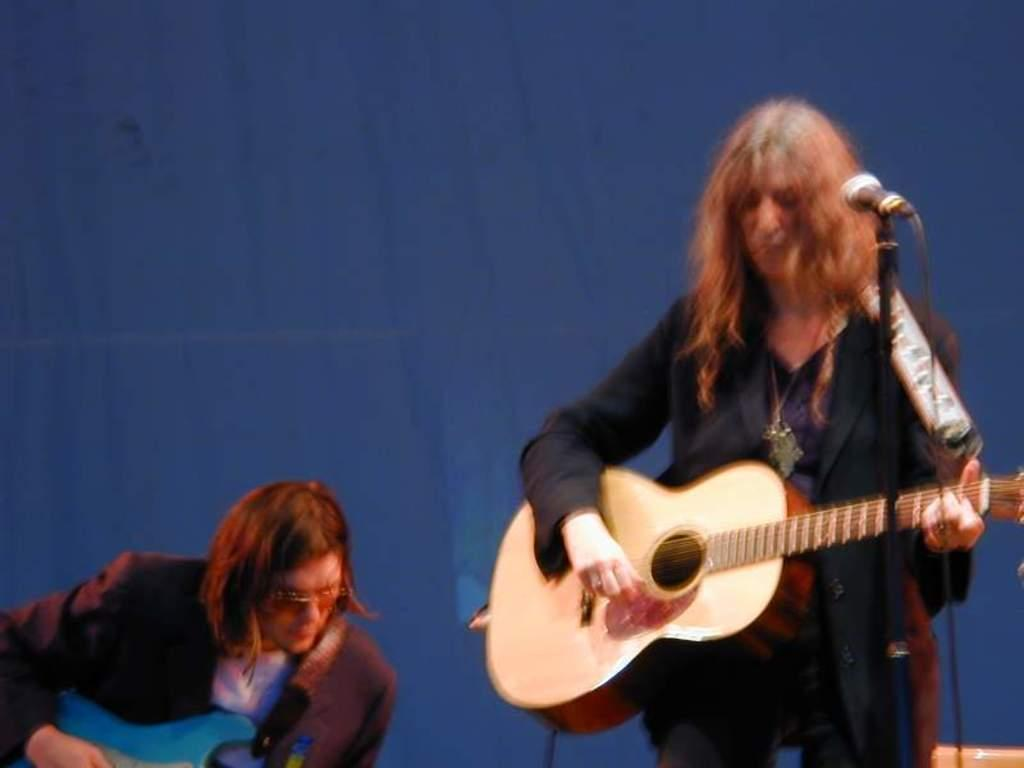How many people are in the image? There are two people in the image. What are the people doing in the image? Both people are playing musical instruments. How can you describe the clothing of the people in the image? The people are wearing colorful dress. Is one of the people in the image a spy? There is no indication in the image that any of the people are spies. How many legs can be seen in the image? The number of legs visible in the image cannot be determined from the provided facts, as the focus is on the people and their musical instruments. 